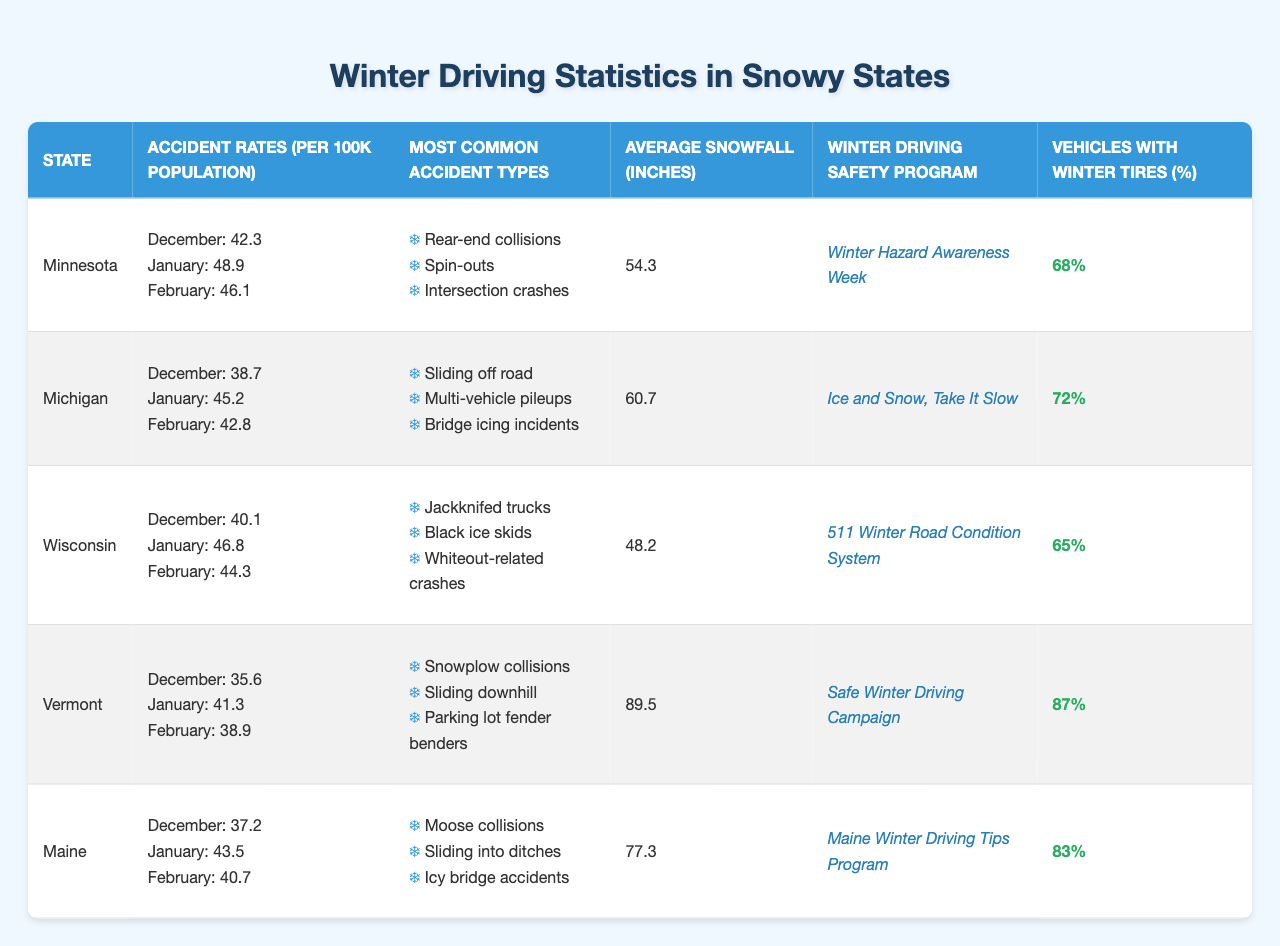What state has the highest accident rate in January? Looking at the table, I see that Minnesota has an accident rate of 48.9 per 100k population in January, which is higher than the other states’ accident rates in the same month.
Answer: Minnesota What is the average snowfall in Vermont? The table lists Vermont's average snowfall as 89.5 inches, which is directly provided in the data.
Answer: 89.5 inches Which state has the lowest percentage of vehicles with winter tires? Wisconsin has the lowest percentage of vehicles with winter tires at 65%, as shown in the percentage column.
Answer: 65% Did Minnesota have a higher accident rate in December or February? In December, Minnesota's accident rate is 42.3, and in February, it is 46.1. Since 46.1 is higher, it had a higher accident rate in February.
Answer: February How many types of accidents are most common in Michigan? The table lists three common accident types for Michigan. Therefore, the total number of types is three.
Answer: 3 Which state has the winter driving safety program named "511 Winter Road Condition System"? According to the table, Wisconsin has the "511 Winter Road Condition System" noted as its winter driving safety program.
Answer: Wisconsin What is the total accident rate for January across all states listed? Adding the accident rates for January: 48.9 (Minnesota) + 45.2 (Michigan) + 46.8 (Wisconsin) + 41.3 (Vermont) + 43.5 (Maine) gives us a total of 225.7 per 100k population across all states.
Answer: 225.7 Which state has the most common accident type of "Rear-end collisions"? The table indicates that rear-end collisions are most common in Minnesota, as listed in its section.
Answer: Minnesota What is the difference in accident rates between January and December for Minnesota? Minnesota's accident rate in January is 48.9 and in December is 42.3. The difference is 48.9 - 42.3 = 6.6 per 100k population.
Answer: 6.6 If Vermont has 89.5 inches of average snowfall and Minnesota has 54.3 inches, what is the difference in inches? The difference in average snowfall between Vermont and Minnesota is 89.5 - 54.3 = 35.2 inches.
Answer: 35.2 inches Which state has the highest percentage of vehicles with winter tires? Vermont has the highest percentage of vehicles with winter tires at 87%, as shown in the corresponding column.
Answer: 87% 